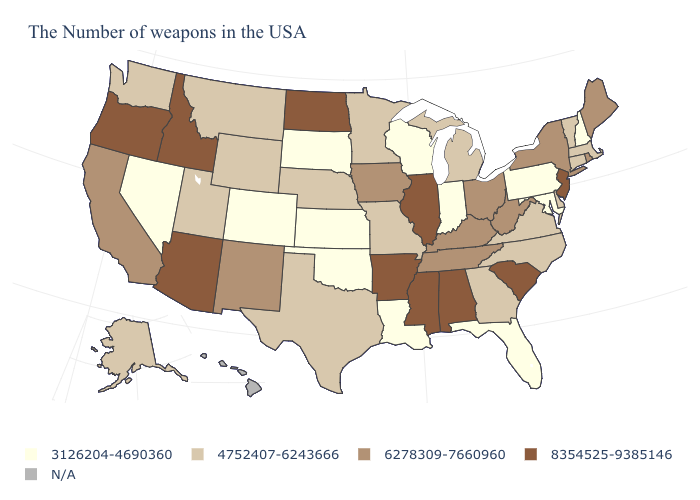Does New Jersey have the highest value in the USA?
Give a very brief answer. Yes. Name the states that have a value in the range 3126204-4690360?
Be succinct. New Hampshire, Maryland, Pennsylvania, Florida, Indiana, Wisconsin, Louisiana, Kansas, Oklahoma, South Dakota, Colorado, Nevada. What is the value of Pennsylvania?
Give a very brief answer. 3126204-4690360. Does the first symbol in the legend represent the smallest category?
Quick response, please. Yes. Among the states that border Massachusetts , which have the lowest value?
Short answer required. New Hampshire. What is the value of Alabama?
Short answer required. 8354525-9385146. Which states have the lowest value in the USA?
Quick response, please. New Hampshire, Maryland, Pennsylvania, Florida, Indiana, Wisconsin, Louisiana, Kansas, Oklahoma, South Dakota, Colorado, Nevada. Name the states that have a value in the range N/A?
Keep it brief. Hawaii. Among the states that border Minnesota , which have the highest value?
Concise answer only. North Dakota. Which states have the lowest value in the USA?
Quick response, please. New Hampshire, Maryland, Pennsylvania, Florida, Indiana, Wisconsin, Louisiana, Kansas, Oklahoma, South Dakota, Colorado, Nevada. What is the value of Alaska?
Give a very brief answer. 4752407-6243666. Name the states that have a value in the range 3126204-4690360?
Be succinct. New Hampshire, Maryland, Pennsylvania, Florida, Indiana, Wisconsin, Louisiana, Kansas, Oklahoma, South Dakota, Colorado, Nevada. What is the value of Connecticut?
Keep it brief. 4752407-6243666. Does Wisconsin have the highest value in the MidWest?
Give a very brief answer. No. What is the value of Arkansas?
Keep it brief. 8354525-9385146. 